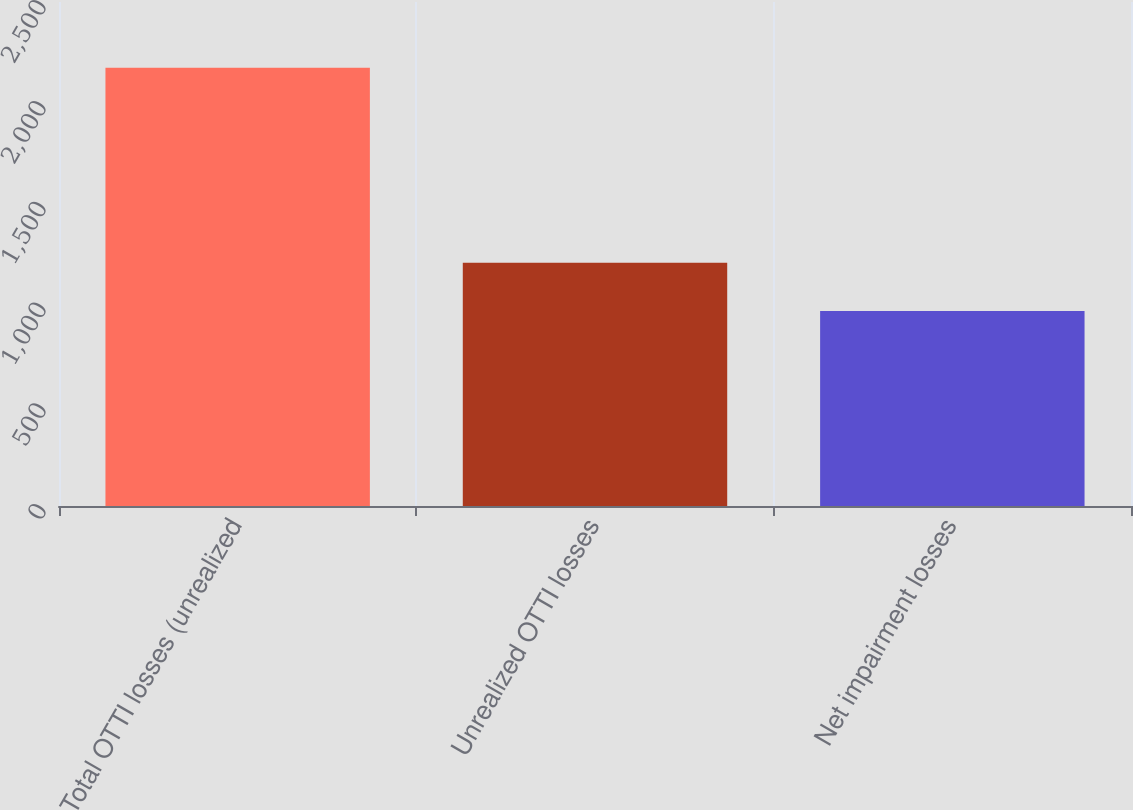<chart> <loc_0><loc_0><loc_500><loc_500><bar_chart><fcel>Total OTTI losses (unrealized<fcel>Unrealized OTTI losses<fcel>Net impairment losses<nl><fcel>2174<fcel>1207<fcel>967<nl></chart> 